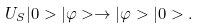<formula> <loc_0><loc_0><loc_500><loc_500>U _ { S } | 0 > | \varphi > \rightarrow | \varphi > | 0 > .</formula> 